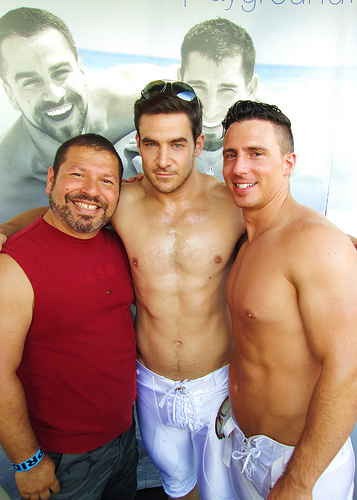<image>
Is the shirt on the man? No. The shirt is not positioned on the man. They may be near each other, but the shirt is not supported by or resting on top of the man. 